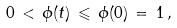<formula> <loc_0><loc_0><loc_500><loc_500>0 \, < \, \phi ( t ) \, \leqslant \, \phi ( 0 ) \, = \, 1 \, ,</formula> 